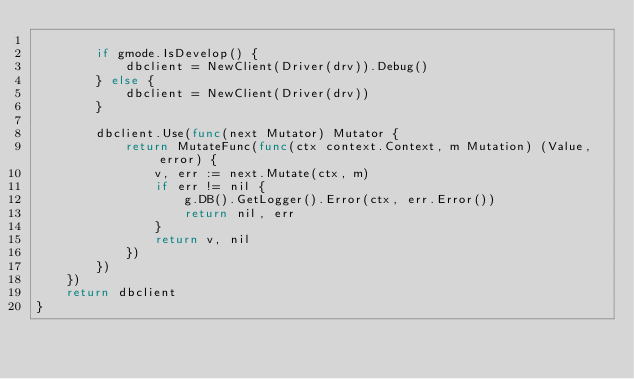Convert code to text. <code><loc_0><loc_0><loc_500><loc_500><_Go_>
		if gmode.IsDevelop() {
			dbclient = NewClient(Driver(drv)).Debug()
		} else {
			dbclient = NewClient(Driver(drv))
		}

		dbclient.Use(func(next Mutator) Mutator {
			return MutateFunc(func(ctx context.Context, m Mutation) (Value, error) {
				v, err := next.Mutate(ctx, m)
				if err != nil {
					g.DB().GetLogger().Error(ctx, err.Error())
					return nil, err
				}
				return v, nil
			})
		})
	})
	return dbclient
}
</code> 